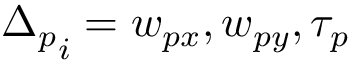Convert formula to latex. <formula><loc_0><loc_0><loc_500><loc_500>{ \Delta _ { p } } _ { i } = w _ { p x } , w _ { p y } , \tau _ { p }</formula> 